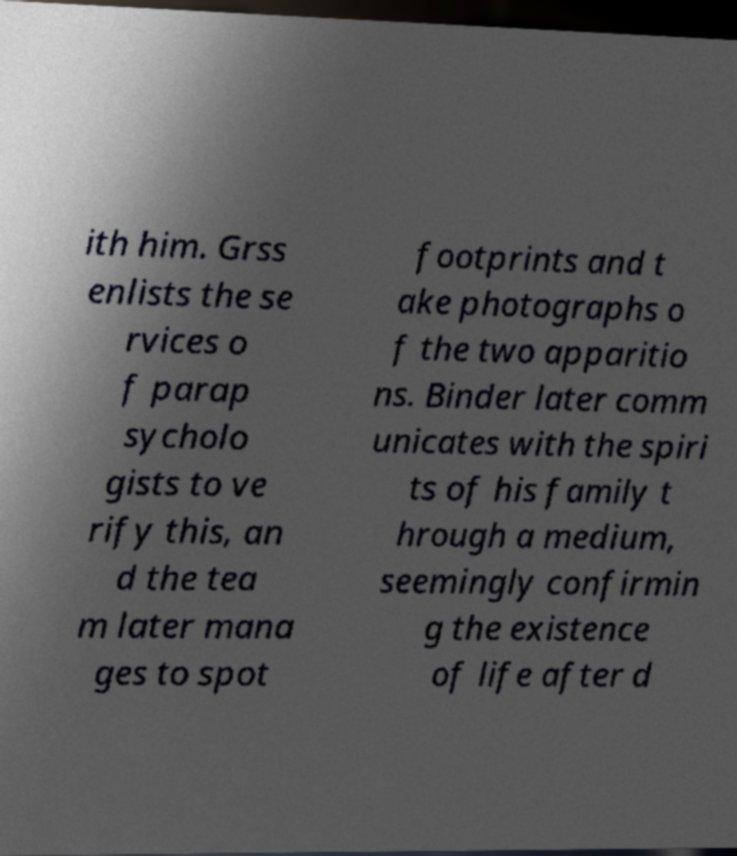There's text embedded in this image that I need extracted. Can you transcribe it verbatim? ith him. Grss enlists the se rvices o f parap sycholo gists to ve rify this, an d the tea m later mana ges to spot footprints and t ake photographs o f the two apparitio ns. Binder later comm unicates with the spiri ts of his family t hrough a medium, seemingly confirmin g the existence of life after d 